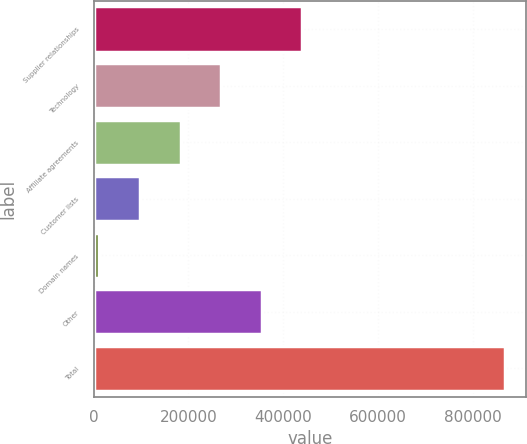Convert chart. <chart><loc_0><loc_0><loc_500><loc_500><bar_chart><fcel>Supplier relationships<fcel>Technology<fcel>Affiliate agreements<fcel>Customer lists<fcel>Domain names<fcel>Other<fcel>Total<nl><fcel>440256<fcel>269078<fcel>183488<fcel>97898.5<fcel>12309<fcel>354667<fcel>868204<nl></chart> 